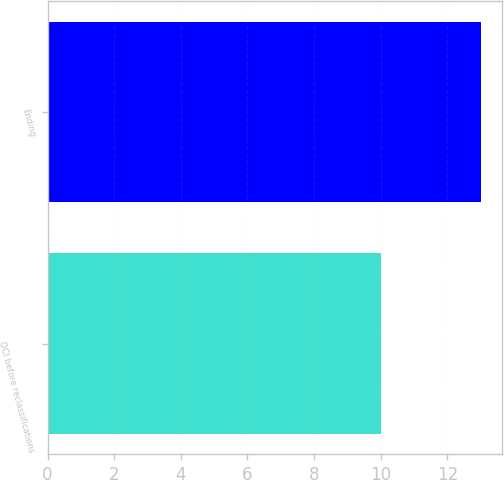Convert chart to OTSL. <chart><loc_0><loc_0><loc_500><loc_500><bar_chart><fcel>OCI before reclassifications<fcel>Ending<nl><fcel>10<fcel>13<nl></chart> 